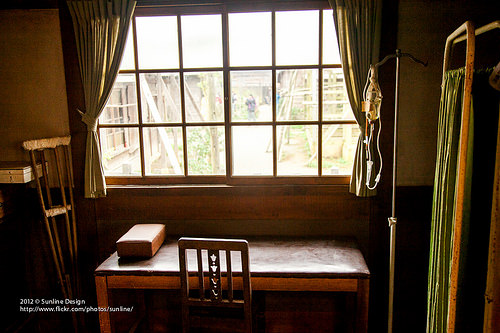<image>
Is the crutches to the right of the table? No. The crutches is not to the right of the table. The horizontal positioning shows a different relationship. Where is the chair in relation to the window? Is it next to the window? No. The chair is not positioned next to the window. They are located in different areas of the scene. Where is the chest in relation to the chair? Is it above the chair? No. The chest is not positioned above the chair. The vertical arrangement shows a different relationship. 